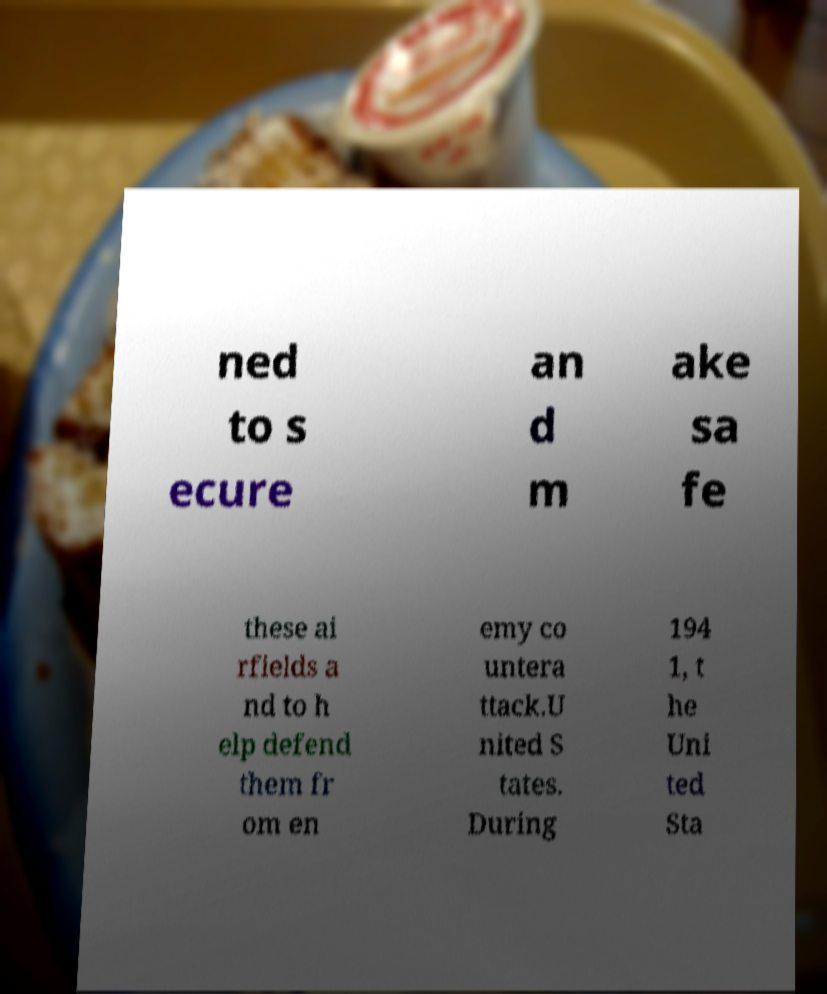Can you read and provide the text displayed in the image?This photo seems to have some interesting text. Can you extract and type it out for me? ned to s ecure an d m ake sa fe these ai rfields a nd to h elp defend them fr om en emy co untera ttack.U nited S tates. During 194 1, t he Uni ted Sta 